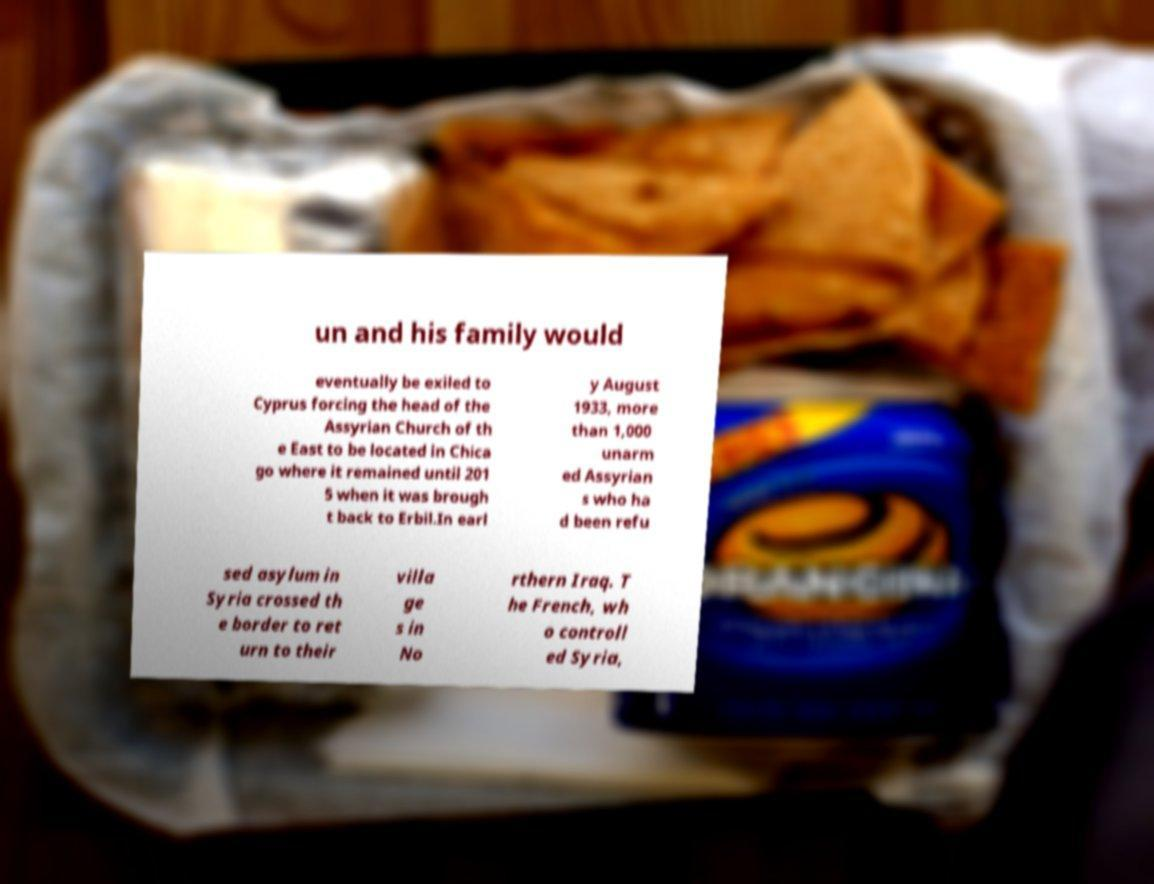Please read and relay the text visible in this image. What does it say? un and his family would eventually be exiled to Cyprus forcing the head of the Assyrian Church of th e East to be located in Chica go where it remained until 201 5 when it was brough t back to Erbil.In earl y August 1933, more than 1,000 unarm ed Assyrian s who ha d been refu sed asylum in Syria crossed th e border to ret urn to their villa ge s in No rthern Iraq. T he French, wh o controll ed Syria, 